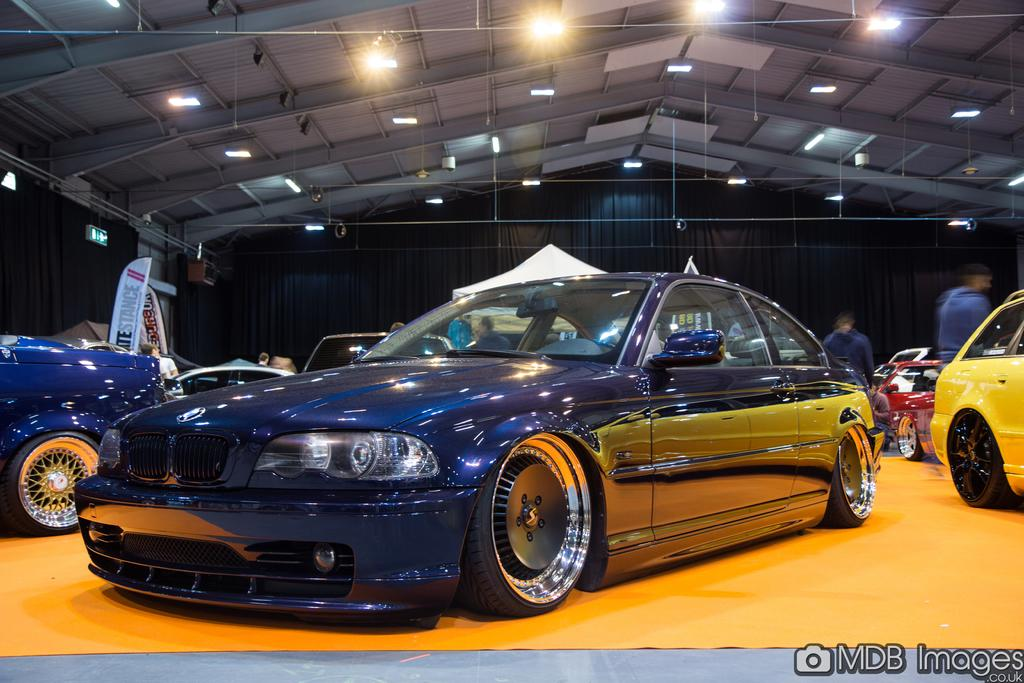What type of structure can be seen in the image? There is a shed in the image. What can be seen illuminating the area in the image? There are lights in the image. What type of window treatment is present in the image? There are curtains in the image. What material is used to create a barrier or surface in the image? There are boards in the image. What type of temporary shelter is visible in the image? There is a tent in the image. What type of transportation is present in the image? There are vehicles in the image. What type of flooring is present in the image? There is a yellow carpet in the image. Who or what is present in the image? There are people in the image. What objects can be seen in the image? There are objects in the image. Where is the gate located in the image? There is no gate present in the image. What type of container is used for bathing in the image? There is no tub present in the image. 